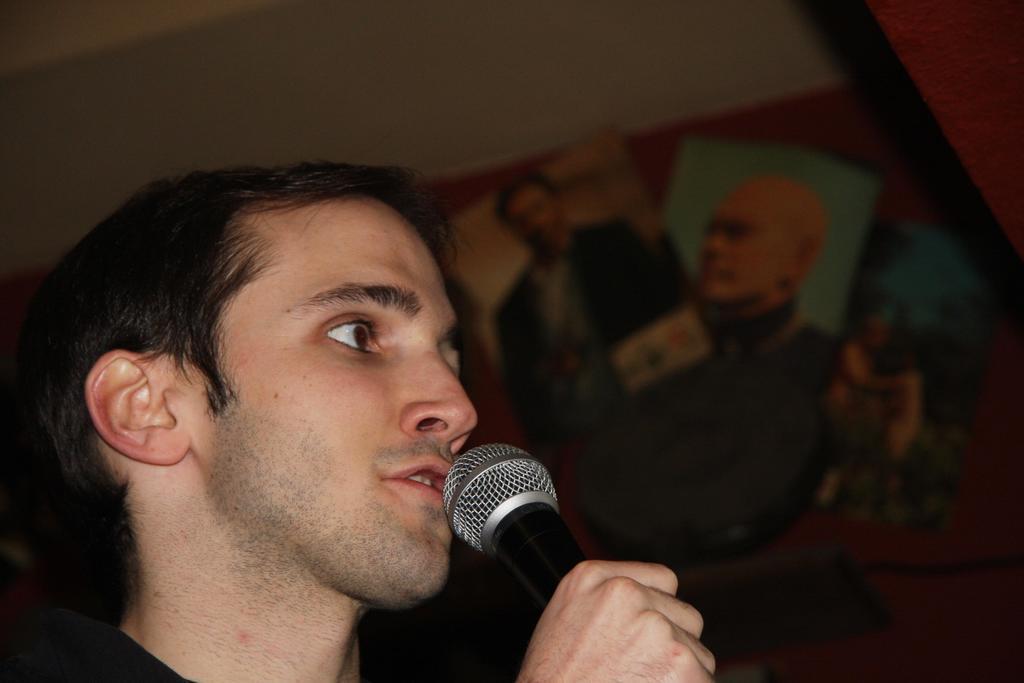Please provide a concise description of this image. In the picture I can see a person holding the microphone. 